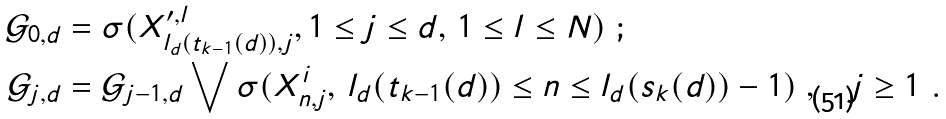<formula> <loc_0><loc_0><loc_500><loc_500>\mathcal { G } _ { 0 , d } & = \sigma ( X _ { l _ { d } ( t _ { k - 1 } ( d ) ) , j } ^ { \prime , l } , 1 \leq j \leq d , \, 1 \leq l \leq N ) \ ; \\ \mathcal { G } _ { j , d } & = \mathcal { G } _ { j - 1 , d } \bigvee \sigma ( X _ { n , j } ^ { i } , \, l _ { d } ( t _ { k - 1 } ( d ) ) \leq n \leq l _ { d } ( s _ { k } ( d ) ) - 1 ) \ , \quad j \geq 1 \ .</formula> 